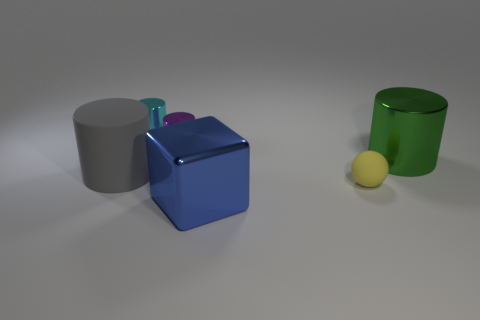Can you estimate the relative size of the objects in the image? Relative to each other, the large blue block is the biggest object. The grey and green cylinders are similar in height but vary in width, with the green being wider. The small purple cylinder is the smallest in height, and the yellow ball appears to be the smallest object in terms of overall dimensions. 